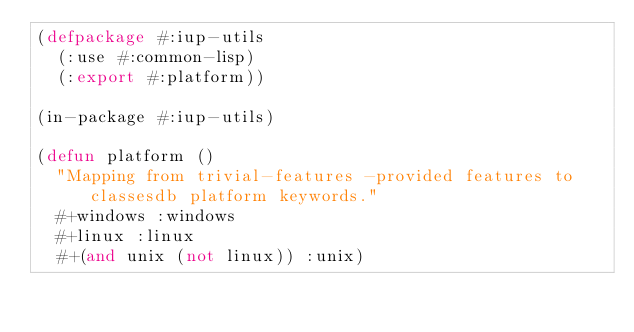<code> <loc_0><loc_0><loc_500><loc_500><_Lisp_>(defpackage #:iup-utils
  (:use #:common-lisp)
  (:export #:platform))

(in-package #:iup-utils)

(defun platform ()
  "Mapping from trivial-features -provided features to classesdb platform keywords."
  #+windows :windows
  #+linux :linux
  #+(and unix (not linux)) :unix)
</code> 